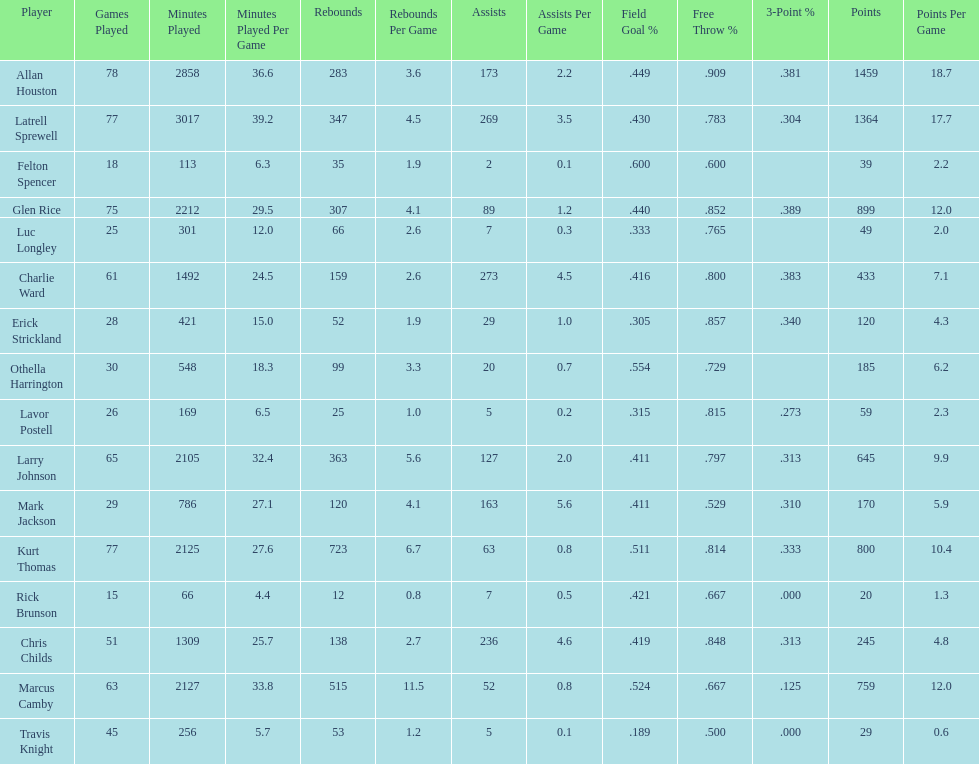Did kurt thomas play more or less than 2126 minutes? Less. 